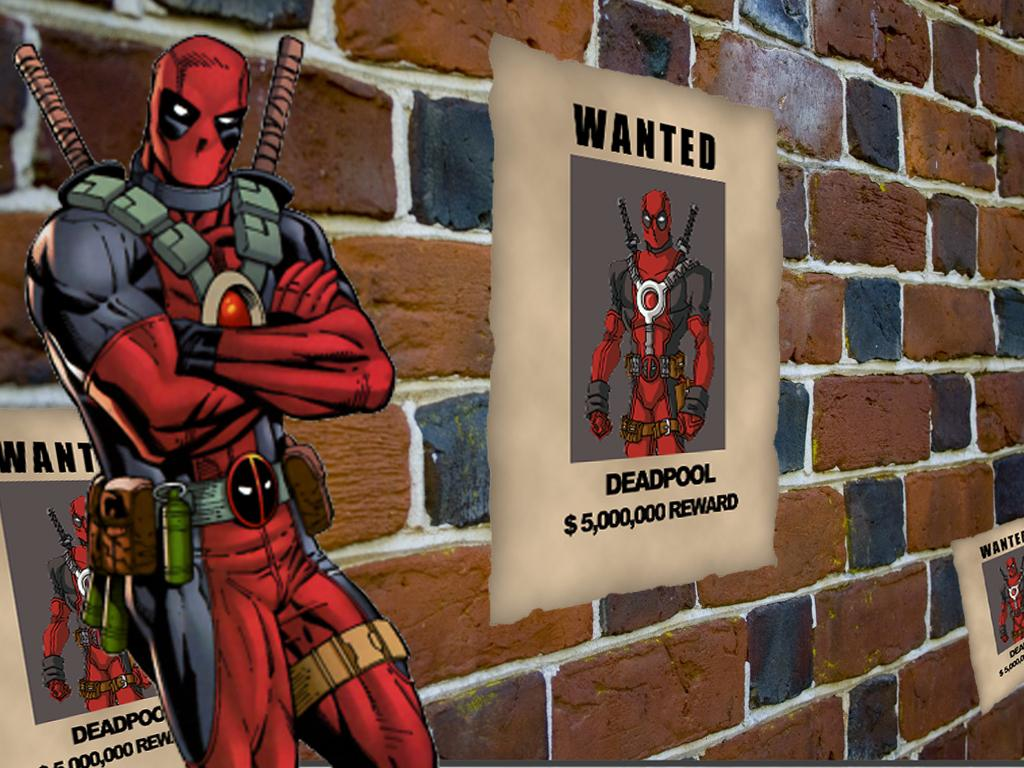Provide a one-sentence caption for the provided image. A Deadpool wanted advertisement offering a $5,000,000 reward. 